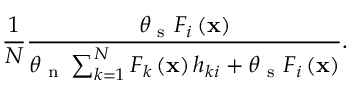<formula> <loc_0><loc_0><loc_500><loc_500>\frac { 1 } { N } \frac { \theta _ { s } F _ { i } \left ( x \right ) } { \theta _ { n } \sum _ { k = 1 } ^ { N } F _ { k } \left ( x \right ) h _ { k i } + \theta _ { s } F _ { i } \left ( x \right ) } .</formula> 